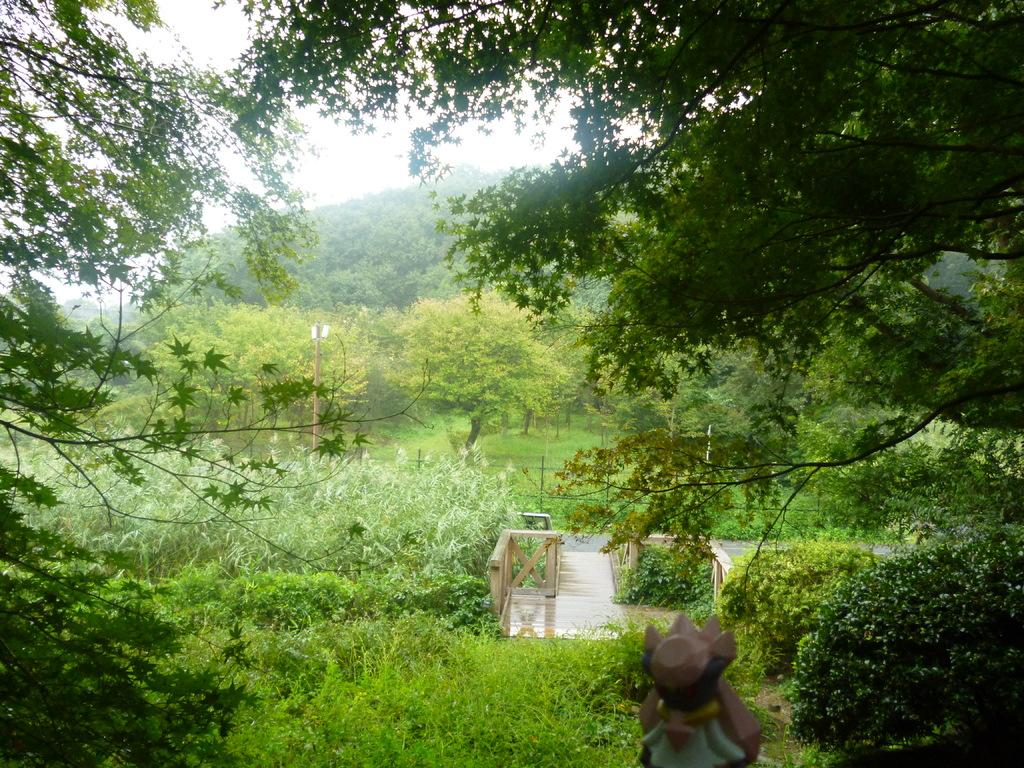What type of vegetation can be seen in the image? There are trees and plants in the image. What material is used for the railing in the image? The railing in the image is made of wood. What type of path is present in the image? There is a wooden path in the image. What can be seen in the background of the image? The sky is visible in the background of the image. Can you tell me the price of the ship on the wooden path in the image? There is no ship present in the image, so it is not possible to determine the price of a ship. 